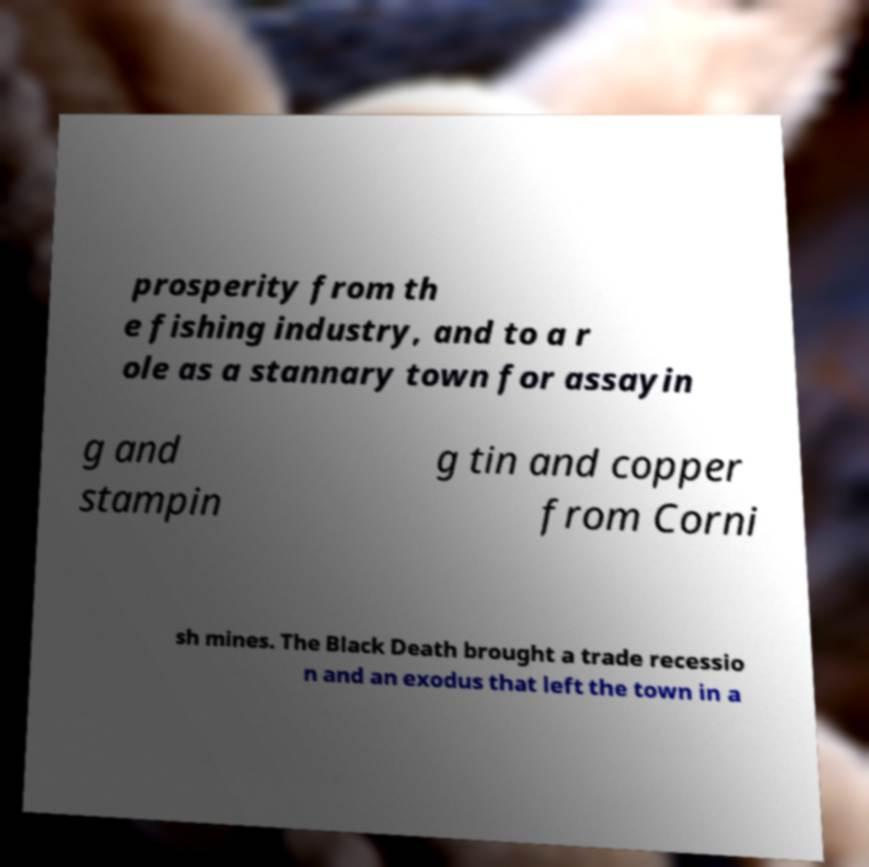Can you read and provide the text displayed in the image?This photo seems to have some interesting text. Can you extract and type it out for me? prosperity from th e fishing industry, and to a r ole as a stannary town for assayin g and stampin g tin and copper from Corni sh mines. The Black Death brought a trade recessio n and an exodus that left the town in a 